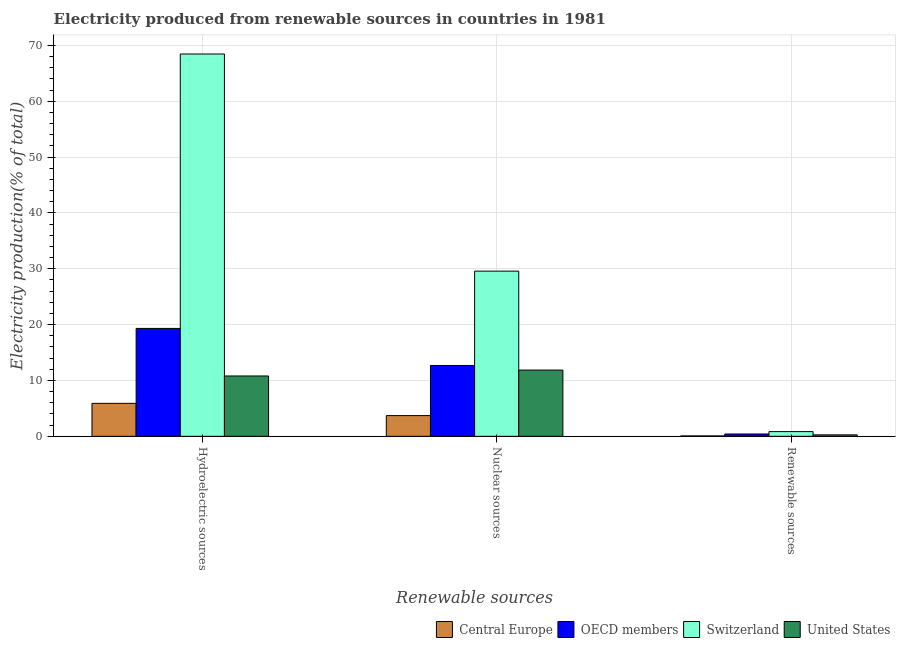How many different coloured bars are there?
Offer a very short reply. 4. Are the number of bars on each tick of the X-axis equal?
Ensure brevity in your answer.  Yes. How many bars are there on the 3rd tick from the right?
Offer a very short reply. 4. What is the label of the 1st group of bars from the left?
Give a very brief answer. Hydroelectric sources. What is the percentage of electricity produced by hydroelectric sources in Switzerland?
Offer a very short reply. 68.45. Across all countries, what is the maximum percentage of electricity produced by renewable sources?
Provide a short and direct response. 0.84. Across all countries, what is the minimum percentage of electricity produced by renewable sources?
Provide a short and direct response. 0.07. In which country was the percentage of electricity produced by nuclear sources maximum?
Provide a short and direct response. Switzerland. In which country was the percentage of electricity produced by renewable sources minimum?
Your answer should be compact. Central Europe. What is the total percentage of electricity produced by nuclear sources in the graph?
Your response must be concise. 57.83. What is the difference between the percentage of electricity produced by renewable sources in Switzerland and that in OECD members?
Offer a very short reply. 0.43. What is the difference between the percentage of electricity produced by renewable sources in OECD members and the percentage of electricity produced by nuclear sources in United States?
Your answer should be compact. -11.45. What is the average percentage of electricity produced by renewable sources per country?
Offer a very short reply. 0.4. What is the difference between the percentage of electricity produced by renewable sources and percentage of electricity produced by nuclear sources in Switzerland?
Provide a succinct answer. -28.73. What is the ratio of the percentage of electricity produced by renewable sources in Switzerland to that in Central Europe?
Your answer should be very brief. 12.02. Is the percentage of electricity produced by nuclear sources in OECD members less than that in Central Europe?
Make the answer very short. No. Is the difference between the percentage of electricity produced by hydroelectric sources in United States and Central Europe greater than the difference between the percentage of electricity produced by nuclear sources in United States and Central Europe?
Provide a short and direct response. No. What is the difference between the highest and the second highest percentage of electricity produced by hydroelectric sources?
Offer a terse response. 49.13. What is the difference between the highest and the lowest percentage of electricity produced by renewable sources?
Give a very brief answer. 0.77. What does the 1st bar from the left in Nuclear sources represents?
Your answer should be very brief. Central Europe. What does the 4th bar from the right in Renewable sources represents?
Ensure brevity in your answer.  Central Europe. Is it the case that in every country, the sum of the percentage of electricity produced by hydroelectric sources and percentage of electricity produced by nuclear sources is greater than the percentage of electricity produced by renewable sources?
Offer a terse response. Yes. How many bars are there?
Offer a very short reply. 12. Are all the bars in the graph horizontal?
Your answer should be compact. No. How many countries are there in the graph?
Offer a very short reply. 4. Are the values on the major ticks of Y-axis written in scientific E-notation?
Offer a terse response. No. How many legend labels are there?
Offer a terse response. 4. What is the title of the graph?
Offer a very short reply. Electricity produced from renewable sources in countries in 1981. What is the label or title of the X-axis?
Ensure brevity in your answer.  Renewable sources. What is the Electricity production(% of total) in Central Europe in Hydroelectric sources?
Provide a short and direct response. 5.9. What is the Electricity production(% of total) in OECD members in Hydroelectric sources?
Provide a succinct answer. 19.32. What is the Electricity production(% of total) of Switzerland in Hydroelectric sources?
Give a very brief answer. 68.45. What is the Electricity production(% of total) of United States in Hydroelectric sources?
Offer a very short reply. 10.8. What is the Electricity production(% of total) of Central Europe in Nuclear sources?
Keep it short and to the point. 3.71. What is the Electricity production(% of total) of OECD members in Nuclear sources?
Provide a succinct answer. 12.69. What is the Electricity production(% of total) in Switzerland in Nuclear sources?
Provide a short and direct response. 29.58. What is the Electricity production(% of total) of United States in Nuclear sources?
Provide a short and direct response. 11.86. What is the Electricity production(% of total) of Central Europe in Renewable sources?
Provide a short and direct response. 0.07. What is the Electricity production(% of total) of OECD members in Renewable sources?
Make the answer very short. 0.41. What is the Electricity production(% of total) of Switzerland in Renewable sources?
Your response must be concise. 0.84. What is the Electricity production(% of total) of United States in Renewable sources?
Give a very brief answer. 0.26. Across all Renewable sources, what is the maximum Electricity production(% of total) of Central Europe?
Your response must be concise. 5.9. Across all Renewable sources, what is the maximum Electricity production(% of total) of OECD members?
Offer a terse response. 19.32. Across all Renewable sources, what is the maximum Electricity production(% of total) of Switzerland?
Provide a succinct answer. 68.45. Across all Renewable sources, what is the maximum Electricity production(% of total) of United States?
Offer a very short reply. 11.86. Across all Renewable sources, what is the minimum Electricity production(% of total) of Central Europe?
Make the answer very short. 0.07. Across all Renewable sources, what is the minimum Electricity production(% of total) of OECD members?
Offer a terse response. 0.41. Across all Renewable sources, what is the minimum Electricity production(% of total) in Switzerland?
Keep it short and to the point. 0.84. Across all Renewable sources, what is the minimum Electricity production(% of total) of United States?
Offer a very short reply. 0.26. What is the total Electricity production(% of total) of Central Europe in the graph?
Provide a succinct answer. 9.68. What is the total Electricity production(% of total) in OECD members in the graph?
Your response must be concise. 32.42. What is the total Electricity production(% of total) in Switzerland in the graph?
Your response must be concise. 98.87. What is the total Electricity production(% of total) in United States in the graph?
Your answer should be compact. 22.93. What is the difference between the Electricity production(% of total) in Central Europe in Hydroelectric sources and that in Nuclear sources?
Offer a terse response. 2.19. What is the difference between the Electricity production(% of total) of OECD members in Hydroelectric sources and that in Nuclear sources?
Your response must be concise. 6.63. What is the difference between the Electricity production(% of total) of Switzerland in Hydroelectric sources and that in Nuclear sources?
Give a very brief answer. 38.88. What is the difference between the Electricity production(% of total) in United States in Hydroelectric sources and that in Nuclear sources?
Provide a succinct answer. -1.06. What is the difference between the Electricity production(% of total) in Central Europe in Hydroelectric sources and that in Renewable sources?
Your response must be concise. 5.83. What is the difference between the Electricity production(% of total) of OECD members in Hydroelectric sources and that in Renewable sources?
Make the answer very short. 18.9. What is the difference between the Electricity production(% of total) of Switzerland in Hydroelectric sources and that in Renewable sources?
Your answer should be compact. 67.61. What is the difference between the Electricity production(% of total) in United States in Hydroelectric sources and that in Renewable sources?
Provide a succinct answer. 10.54. What is the difference between the Electricity production(% of total) of Central Europe in Nuclear sources and that in Renewable sources?
Make the answer very short. 3.64. What is the difference between the Electricity production(% of total) of OECD members in Nuclear sources and that in Renewable sources?
Make the answer very short. 12.27. What is the difference between the Electricity production(% of total) in Switzerland in Nuclear sources and that in Renewable sources?
Provide a succinct answer. 28.73. What is the difference between the Electricity production(% of total) in United States in Nuclear sources and that in Renewable sources?
Give a very brief answer. 11.6. What is the difference between the Electricity production(% of total) of Central Europe in Hydroelectric sources and the Electricity production(% of total) of OECD members in Nuclear sources?
Your response must be concise. -6.78. What is the difference between the Electricity production(% of total) in Central Europe in Hydroelectric sources and the Electricity production(% of total) in Switzerland in Nuclear sources?
Make the answer very short. -23.67. What is the difference between the Electricity production(% of total) of Central Europe in Hydroelectric sources and the Electricity production(% of total) of United States in Nuclear sources?
Ensure brevity in your answer.  -5.96. What is the difference between the Electricity production(% of total) of OECD members in Hydroelectric sources and the Electricity production(% of total) of Switzerland in Nuclear sources?
Your response must be concise. -10.26. What is the difference between the Electricity production(% of total) in OECD members in Hydroelectric sources and the Electricity production(% of total) in United States in Nuclear sources?
Keep it short and to the point. 7.46. What is the difference between the Electricity production(% of total) of Switzerland in Hydroelectric sources and the Electricity production(% of total) of United States in Nuclear sources?
Keep it short and to the point. 56.59. What is the difference between the Electricity production(% of total) of Central Europe in Hydroelectric sources and the Electricity production(% of total) of OECD members in Renewable sources?
Offer a terse response. 5.49. What is the difference between the Electricity production(% of total) of Central Europe in Hydroelectric sources and the Electricity production(% of total) of Switzerland in Renewable sources?
Your answer should be compact. 5.06. What is the difference between the Electricity production(% of total) in Central Europe in Hydroelectric sources and the Electricity production(% of total) in United States in Renewable sources?
Provide a short and direct response. 5.64. What is the difference between the Electricity production(% of total) in OECD members in Hydroelectric sources and the Electricity production(% of total) in Switzerland in Renewable sources?
Keep it short and to the point. 18.48. What is the difference between the Electricity production(% of total) in OECD members in Hydroelectric sources and the Electricity production(% of total) in United States in Renewable sources?
Your response must be concise. 19.05. What is the difference between the Electricity production(% of total) in Switzerland in Hydroelectric sources and the Electricity production(% of total) in United States in Renewable sources?
Provide a succinct answer. 68.19. What is the difference between the Electricity production(% of total) in Central Europe in Nuclear sources and the Electricity production(% of total) in OECD members in Renewable sources?
Your answer should be compact. 3.29. What is the difference between the Electricity production(% of total) in Central Europe in Nuclear sources and the Electricity production(% of total) in Switzerland in Renewable sources?
Provide a short and direct response. 2.87. What is the difference between the Electricity production(% of total) in Central Europe in Nuclear sources and the Electricity production(% of total) in United States in Renewable sources?
Your response must be concise. 3.44. What is the difference between the Electricity production(% of total) of OECD members in Nuclear sources and the Electricity production(% of total) of Switzerland in Renewable sources?
Provide a short and direct response. 11.85. What is the difference between the Electricity production(% of total) of OECD members in Nuclear sources and the Electricity production(% of total) of United States in Renewable sources?
Make the answer very short. 12.42. What is the difference between the Electricity production(% of total) of Switzerland in Nuclear sources and the Electricity production(% of total) of United States in Renewable sources?
Make the answer very short. 29.31. What is the average Electricity production(% of total) in Central Europe per Renewable sources?
Give a very brief answer. 3.23. What is the average Electricity production(% of total) of OECD members per Renewable sources?
Offer a very short reply. 10.81. What is the average Electricity production(% of total) of Switzerland per Renewable sources?
Make the answer very short. 32.96. What is the average Electricity production(% of total) of United States per Renewable sources?
Offer a very short reply. 7.64. What is the difference between the Electricity production(% of total) in Central Europe and Electricity production(% of total) in OECD members in Hydroelectric sources?
Provide a short and direct response. -13.41. What is the difference between the Electricity production(% of total) in Central Europe and Electricity production(% of total) in Switzerland in Hydroelectric sources?
Ensure brevity in your answer.  -62.55. What is the difference between the Electricity production(% of total) in Central Europe and Electricity production(% of total) in United States in Hydroelectric sources?
Offer a very short reply. -4.9. What is the difference between the Electricity production(% of total) in OECD members and Electricity production(% of total) in Switzerland in Hydroelectric sources?
Keep it short and to the point. -49.13. What is the difference between the Electricity production(% of total) of OECD members and Electricity production(% of total) of United States in Hydroelectric sources?
Your answer should be compact. 8.51. What is the difference between the Electricity production(% of total) in Switzerland and Electricity production(% of total) in United States in Hydroelectric sources?
Give a very brief answer. 57.65. What is the difference between the Electricity production(% of total) of Central Europe and Electricity production(% of total) of OECD members in Nuclear sources?
Your answer should be compact. -8.98. What is the difference between the Electricity production(% of total) of Central Europe and Electricity production(% of total) of Switzerland in Nuclear sources?
Offer a terse response. -25.87. What is the difference between the Electricity production(% of total) of Central Europe and Electricity production(% of total) of United States in Nuclear sources?
Provide a succinct answer. -8.15. What is the difference between the Electricity production(% of total) in OECD members and Electricity production(% of total) in Switzerland in Nuclear sources?
Give a very brief answer. -16.89. What is the difference between the Electricity production(% of total) in OECD members and Electricity production(% of total) in United States in Nuclear sources?
Give a very brief answer. 0.83. What is the difference between the Electricity production(% of total) of Switzerland and Electricity production(% of total) of United States in Nuclear sources?
Make the answer very short. 17.72. What is the difference between the Electricity production(% of total) of Central Europe and Electricity production(% of total) of OECD members in Renewable sources?
Your answer should be compact. -0.34. What is the difference between the Electricity production(% of total) in Central Europe and Electricity production(% of total) in Switzerland in Renewable sources?
Ensure brevity in your answer.  -0.77. What is the difference between the Electricity production(% of total) in Central Europe and Electricity production(% of total) in United States in Renewable sources?
Provide a succinct answer. -0.19. What is the difference between the Electricity production(% of total) of OECD members and Electricity production(% of total) of Switzerland in Renewable sources?
Your answer should be very brief. -0.43. What is the difference between the Electricity production(% of total) in OECD members and Electricity production(% of total) in United States in Renewable sources?
Your answer should be very brief. 0.15. What is the difference between the Electricity production(% of total) in Switzerland and Electricity production(% of total) in United States in Renewable sources?
Provide a succinct answer. 0.58. What is the ratio of the Electricity production(% of total) of Central Europe in Hydroelectric sources to that in Nuclear sources?
Give a very brief answer. 1.59. What is the ratio of the Electricity production(% of total) of OECD members in Hydroelectric sources to that in Nuclear sources?
Provide a short and direct response. 1.52. What is the ratio of the Electricity production(% of total) of Switzerland in Hydroelectric sources to that in Nuclear sources?
Keep it short and to the point. 2.31. What is the ratio of the Electricity production(% of total) of United States in Hydroelectric sources to that in Nuclear sources?
Give a very brief answer. 0.91. What is the ratio of the Electricity production(% of total) in Central Europe in Hydroelectric sources to that in Renewable sources?
Your answer should be very brief. 84.34. What is the ratio of the Electricity production(% of total) of OECD members in Hydroelectric sources to that in Renewable sources?
Your response must be concise. 46.68. What is the ratio of the Electricity production(% of total) of Switzerland in Hydroelectric sources to that in Renewable sources?
Make the answer very short. 81.38. What is the ratio of the Electricity production(% of total) of United States in Hydroelectric sources to that in Renewable sources?
Provide a succinct answer. 41. What is the ratio of the Electricity production(% of total) of Central Europe in Nuclear sources to that in Renewable sources?
Keep it short and to the point. 52.98. What is the ratio of the Electricity production(% of total) in OECD members in Nuclear sources to that in Renewable sources?
Ensure brevity in your answer.  30.66. What is the ratio of the Electricity production(% of total) of Switzerland in Nuclear sources to that in Renewable sources?
Provide a succinct answer. 35.16. What is the ratio of the Electricity production(% of total) in United States in Nuclear sources to that in Renewable sources?
Offer a terse response. 45.01. What is the difference between the highest and the second highest Electricity production(% of total) in Central Europe?
Your response must be concise. 2.19. What is the difference between the highest and the second highest Electricity production(% of total) in OECD members?
Provide a short and direct response. 6.63. What is the difference between the highest and the second highest Electricity production(% of total) of Switzerland?
Your answer should be very brief. 38.88. What is the difference between the highest and the second highest Electricity production(% of total) in United States?
Offer a terse response. 1.06. What is the difference between the highest and the lowest Electricity production(% of total) in Central Europe?
Your answer should be very brief. 5.83. What is the difference between the highest and the lowest Electricity production(% of total) of OECD members?
Give a very brief answer. 18.9. What is the difference between the highest and the lowest Electricity production(% of total) in Switzerland?
Give a very brief answer. 67.61. What is the difference between the highest and the lowest Electricity production(% of total) of United States?
Your answer should be compact. 11.6. 